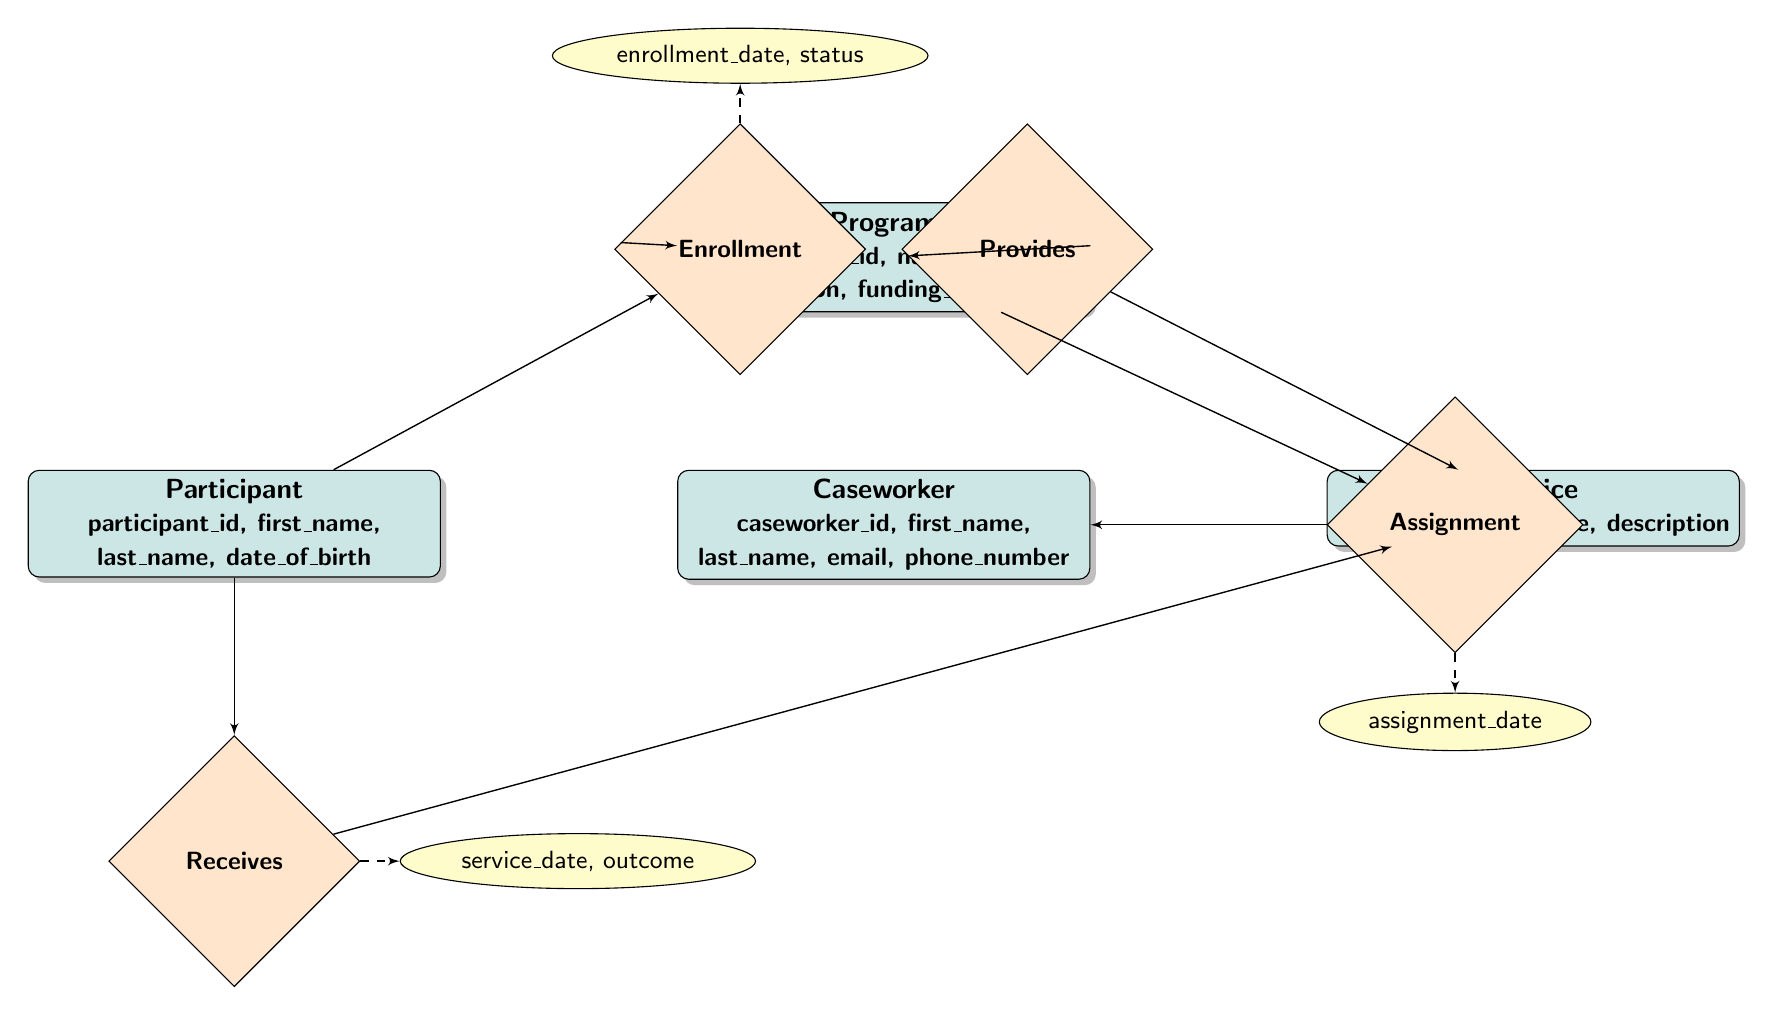What entities are represented in the diagram? The entities are found in the entity nodes, which include Program, Participant, Service, and Caseworker.
Answer: Program, Participant, Service, Caseworker What is the relationship type between Participant and Program? The relationship connecting Participant and Program is labeled as Enrollment in the diagram, indicating that participants can enroll in programs.
Answer: Enrollment How many attributes are associated with the Program entity? To determine this, count the attributes listed under the Program entity, which are program_id, name, description, and funding_source, totaling four attributes.
Answer: 4 What attributes are associated with the Enrollment relationship? The attributes tied to the Enrollment relationship can be found by looking directly at that relationship, which lists enrollment_date and status.
Answer: enrollment_date, status Which entity is assigned to a Program through the Assignment relationship? Looking at the diagram, the entity that is assigned to a Program through the Assignment relationship is the Caseworker, connected by this relationship.
Answer: Caseworker What information is captured when a Participant Receives a Service? This relationship has specific attributes called service_date and outcome, which describe the date the service was provided and the result of that service.
Answer: service_date, outcome How are Services provided to Programs? The relationship between Programs and Services is named Provides, indicating that programs offer specific services as part of their support.
Answer: Provides What denotes the relationship between Caseworker and Program? The relationship that illustrates how Caseworkers interact with Programs is called Assignment, meaning caseworkers are assigned to specific programs.
Answer: Assignment What does the Receives relationship indicate about Participants? The Receives relationship indicates that Participants can receive Services, demonstrating how they benefit from the programs they are enrolled in.
Answer: Participants receive Services 